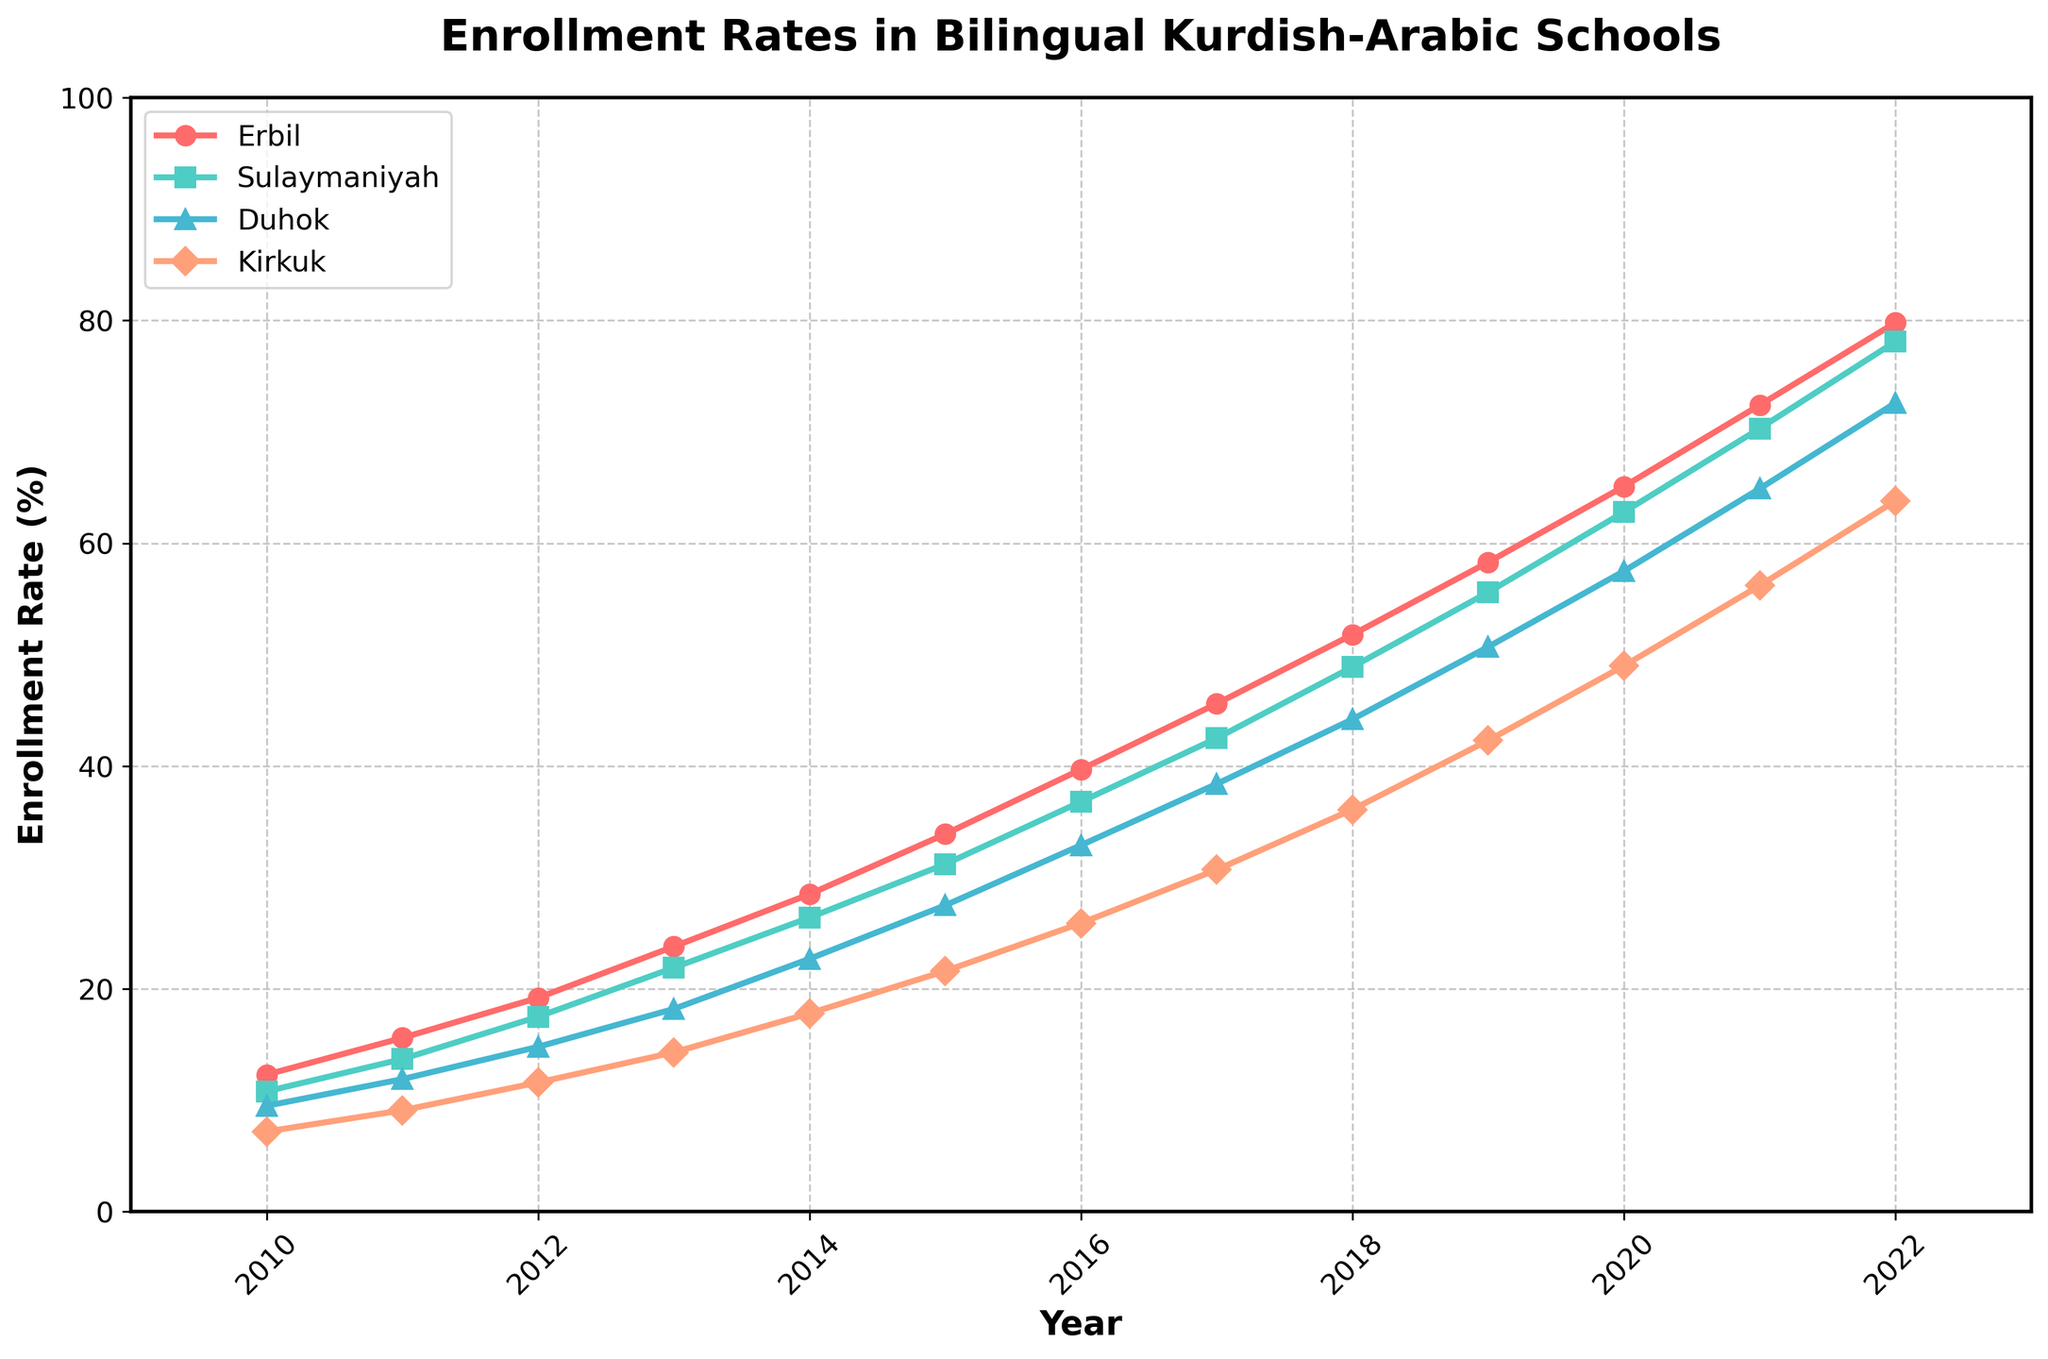What was the enrollment rate in Kirkuk in 2020? To find this, look at the point on the line for Kirkuk (depicted by the orange color) corresponding to the year 2020. This value is on the y-axis.
Answer: 49.0% Which city had the highest enrollment rate in 2022? Locate the lines for all cities in 2022 and compare the heights. The city with the highest point is Erbil.
Answer: Erbil How did the enrollment rate in Sulaymaniyah change from 2010 to 2011? Check the value for Sulaymaniyah in 2010 and 2011 on the y-axis and calculate the difference. (13.7 - 10.8) = 2.9%.
Answer: Increased by 2.9% Which city showed the most consistent year-over-year increase in enrollment rates? Examine the slopes of all lines, focusing on their consistency (steadiness) over each period. The blue-green line for Sulaymaniyah appears most consistent.
Answer: Sulaymaniyah In 2015, which city had a lower enrollment rate than Duhok? Compare the y-axis values for Duhok and other cities in 2015. Kirkuk had a lower rate (21.6) than Duhok (27.5).
Answer: Kirkuk What is the average enrollment rate in Erbil from 2010 to 2015? Sum the values for Erbil from 2010 to 2015 (12.3, 15.6, 19.2, 23.8, 28.5, 33.9) and divide by the number of years (6). (12.3 + 15.6 + 19.2 + 23.8 + 28.5 + 33.9) / 6 = 22.22%.
Answer: 22.22% Which year had the biggest increase in Kirkuk’s enrollment rate from the previous year? Calculate the year-to-year differences for Kirkuk and find the largest leap:
2011: 9.1 - 7.2 = 1.9
2012: 11.6 - 9.1 = 2.5
2013: 14.3 - 11.6 = 2.7
2014: 17.8 - 14.3 = 3.5
2015: 21.6 - 17.8 = 3.8
2016: 25.9 - 21.6 = 4.3
2017: 30.7 - 25.9 = 4.8
2018: 36.1 - 30.7 = 5.4
2019: 42.3 - 36.1 = 6.2
2020: 49.0 - 42.3 = 6.7
2021: 56.2 - 49.0 = 7.2
2022: 63.8 - 56.2 = 7.6. The biggest increase is in 2022.
Answer: 2022 By how much did the total enrollment rate increase across all cities from 2010 to 2022? Sum the enrollment rates for all cities in 2010 and 2022, then find the difference:
2010 total: 12.3 + 10.8 + 9.5 + 7.2 = 39.8
2022 total: 79.8 + 78.1 + 72.6 + 63.8 = 294.3
Increase: 294.3 - 39.8 = 254.5%.
Answer: 254.5% Which two cities had the closest enrollment rates in 2013? Compare the y-axis values for 2013 across all cities to see which two values are nearest: Sulaymaniyah (21.9) and Duhok (18.2). Difference: 21.9 - 18.2 = 3.7.
Answer: Sulaymaniyah and Duhok How many years did it take for the enrollment rate in Erbil to double from its 2010 rate? Initially, in 2010, Erbil had 12.3%. To double: 2 * 12.3 = 24.6%. Check which year is the first where Erbil’s rate surpasses 24.6%. Erbil surpasses it in 2014 with 28.5%. (2014 - 2010) = 4 years.
Answer: 4 years 